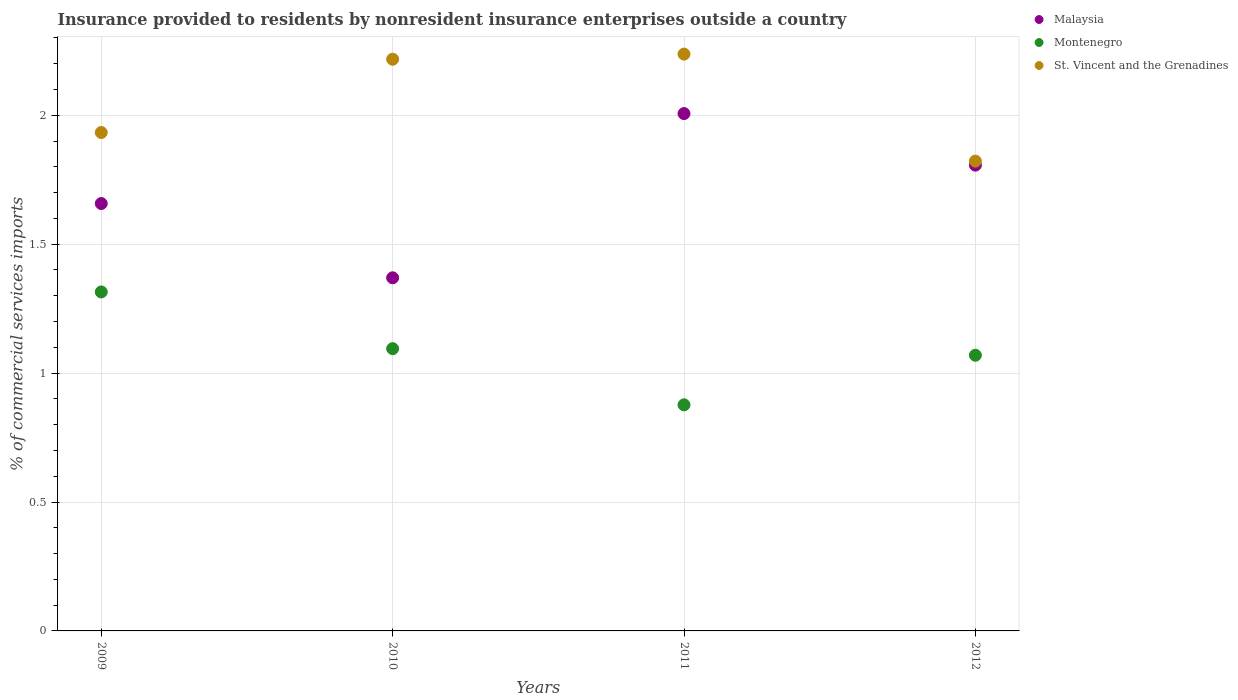How many different coloured dotlines are there?
Make the answer very short. 3. What is the Insurance provided to residents in Malaysia in 2012?
Your answer should be very brief. 1.81. Across all years, what is the maximum Insurance provided to residents in St. Vincent and the Grenadines?
Ensure brevity in your answer.  2.24. Across all years, what is the minimum Insurance provided to residents in Montenegro?
Your response must be concise. 0.88. In which year was the Insurance provided to residents in St. Vincent and the Grenadines maximum?
Offer a very short reply. 2011. What is the total Insurance provided to residents in Montenegro in the graph?
Offer a very short reply. 4.36. What is the difference between the Insurance provided to residents in Malaysia in 2009 and that in 2011?
Make the answer very short. -0.35. What is the difference between the Insurance provided to residents in St. Vincent and the Grenadines in 2010 and the Insurance provided to residents in Montenegro in 2012?
Give a very brief answer. 1.15. What is the average Insurance provided to residents in Montenegro per year?
Provide a succinct answer. 1.09. In the year 2009, what is the difference between the Insurance provided to residents in Malaysia and Insurance provided to residents in St. Vincent and the Grenadines?
Ensure brevity in your answer.  -0.28. What is the ratio of the Insurance provided to residents in Montenegro in 2010 to that in 2012?
Your answer should be compact. 1.02. What is the difference between the highest and the second highest Insurance provided to residents in St. Vincent and the Grenadines?
Ensure brevity in your answer.  0.02. What is the difference between the highest and the lowest Insurance provided to residents in St. Vincent and the Grenadines?
Make the answer very short. 0.42. Is the sum of the Insurance provided to residents in Malaysia in 2011 and 2012 greater than the maximum Insurance provided to residents in Montenegro across all years?
Offer a very short reply. Yes. Is the Insurance provided to residents in St. Vincent and the Grenadines strictly greater than the Insurance provided to residents in Malaysia over the years?
Make the answer very short. Yes. Is the Insurance provided to residents in Malaysia strictly less than the Insurance provided to residents in St. Vincent and the Grenadines over the years?
Offer a terse response. Yes. Does the graph contain any zero values?
Your answer should be very brief. No. Where does the legend appear in the graph?
Provide a succinct answer. Top right. How are the legend labels stacked?
Your answer should be very brief. Vertical. What is the title of the graph?
Make the answer very short. Insurance provided to residents by nonresident insurance enterprises outside a country. Does "Bolivia" appear as one of the legend labels in the graph?
Your response must be concise. No. What is the label or title of the Y-axis?
Offer a terse response. % of commercial services imports. What is the % of commercial services imports of Malaysia in 2009?
Keep it short and to the point. 1.66. What is the % of commercial services imports in Montenegro in 2009?
Make the answer very short. 1.31. What is the % of commercial services imports in St. Vincent and the Grenadines in 2009?
Your answer should be compact. 1.93. What is the % of commercial services imports of Malaysia in 2010?
Offer a terse response. 1.37. What is the % of commercial services imports in Montenegro in 2010?
Your response must be concise. 1.09. What is the % of commercial services imports in St. Vincent and the Grenadines in 2010?
Give a very brief answer. 2.22. What is the % of commercial services imports of Malaysia in 2011?
Keep it short and to the point. 2.01. What is the % of commercial services imports of Montenegro in 2011?
Keep it short and to the point. 0.88. What is the % of commercial services imports of St. Vincent and the Grenadines in 2011?
Offer a terse response. 2.24. What is the % of commercial services imports of Malaysia in 2012?
Your answer should be compact. 1.81. What is the % of commercial services imports in Montenegro in 2012?
Offer a very short reply. 1.07. What is the % of commercial services imports in St. Vincent and the Grenadines in 2012?
Offer a very short reply. 1.82. Across all years, what is the maximum % of commercial services imports of Malaysia?
Keep it short and to the point. 2.01. Across all years, what is the maximum % of commercial services imports in Montenegro?
Ensure brevity in your answer.  1.31. Across all years, what is the maximum % of commercial services imports in St. Vincent and the Grenadines?
Ensure brevity in your answer.  2.24. Across all years, what is the minimum % of commercial services imports in Malaysia?
Your answer should be compact. 1.37. Across all years, what is the minimum % of commercial services imports of Montenegro?
Provide a short and direct response. 0.88. Across all years, what is the minimum % of commercial services imports in St. Vincent and the Grenadines?
Your answer should be compact. 1.82. What is the total % of commercial services imports in Malaysia in the graph?
Give a very brief answer. 6.84. What is the total % of commercial services imports in Montenegro in the graph?
Give a very brief answer. 4.36. What is the total % of commercial services imports in St. Vincent and the Grenadines in the graph?
Your response must be concise. 8.21. What is the difference between the % of commercial services imports of Malaysia in 2009 and that in 2010?
Make the answer very short. 0.29. What is the difference between the % of commercial services imports of Montenegro in 2009 and that in 2010?
Ensure brevity in your answer.  0.22. What is the difference between the % of commercial services imports in St. Vincent and the Grenadines in 2009 and that in 2010?
Provide a succinct answer. -0.28. What is the difference between the % of commercial services imports in Malaysia in 2009 and that in 2011?
Your answer should be very brief. -0.35. What is the difference between the % of commercial services imports in Montenegro in 2009 and that in 2011?
Make the answer very short. 0.44. What is the difference between the % of commercial services imports in St. Vincent and the Grenadines in 2009 and that in 2011?
Your response must be concise. -0.3. What is the difference between the % of commercial services imports in Malaysia in 2009 and that in 2012?
Keep it short and to the point. -0.15. What is the difference between the % of commercial services imports in Montenegro in 2009 and that in 2012?
Your response must be concise. 0.25. What is the difference between the % of commercial services imports of St. Vincent and the Grenadines in 2009 and that in 2012?
Give a very brief answer. 0.11. What is the difference between the % of commercial services imports of Malaysia in 2010 and that in 2011?
Make the answer very short. -0.64. What is the difference between the % of commercial services imports of Montenegro in 2010 and that in 2011?
Give a very brief answer. 0.22. What is the difference between the % of commercial services imports in St. Vincent and the Grenadines in 2010 and that in 2011?
Your answer should be compact. -0.02. What is the difference between the % of commercial services imports of Malaysia in 2010 and that in 2012?
Offer a terse response. -0.44. What is the difference between the % of commercial services imports of Montenegro in 2010 and that in 2012?
Provide a short and direct response. 0.03. What is the difference between the % of commercial services imports of St. Vincent and the Grenadines in 2010 and that in 2012?
Keep it short and to the point. 0.4. What is the difference between the % of commercial services imports of Montenegro in 2011 and that in 2012?
Your answer should be very brief. -0.19. What is the difference between the % of commercial services imports of St. Vincent and the Grenadines in 2011 and that in 2012?
Provide a short and direct response. 0.41. What is the difference between the % of commercial services imports of Malaysia in 2009 and the % of commercial services imports of Montenegro in 2010?
Provide a short and direct response. 0.56. What is the difference between the % of commercial services imports of Malaysia in 2009 and the % of commercial services imports of St. Vincent and the Grenadines in 2010?
Offer a very short reply. -0.56. What is the difference between the % of commercial services imports of Montenegro in 2009 and the % of commercial services imports of St. Vincent and the Grenadines in 2010?
Give a very brief answer. -0.9. What is the difference between the % of commercial services imports in Malaysia in 2009 and the % of commercial services imports in Montenegro in 2011?
Your answer should be very brief. 0.78. What is the difference between the % of commercial services imports of Malaysia in 2009 and the % of commercial services imports of St. Vincent and the Grenadines in 2011?
Offer a very short reply. -0.58. What is the difference between the % of commercial services imports in Montenegro in 2009 and the % of commercial services imports in St. Vincent and the Grenadines in 2011?
Your answer should be very brief. -0.92. What is the difference between the % of commercial services imports in Malaysia in 2009 and the % of commercial services imports in Montenegro in 2012?
Provide a succinct answer. 0.59. What is the difference between the % of commercial services imports of Malaysia in 2009 and the % of commercial services imports of St. Vincent and the Grenadines in 2012?
Give a very brief answer. -0.16. What is the difference between the % of commercial services imports of Montenegro in 2009 and the % of commercial services imports of St. Vincent and the Grenadines in 2012?
Give a very brief answer. -0.51. What is the difference between the % of commercial services imports in Malaysia in 2010 and the % of commercial services imports in Montenegro in 2011?
Offer a very short reply. 0.49. What is the difference between the % of commercial services imports in Malaysia in 2010 and the % of commercial services imports in St. Vincent and the Grenadines in 2011?
Provide a succinct answer. -0.87. What is the difference between the % of commercial services imports in Montenegro in 2010 and the % of commercial services imports in St. Vincent and the Grenadines in 2011?
Keep it short and to the point. -1.14. What is the difference between the % of commercial services imports in Malaysia in 2010 and the % of commercial services imports in Montenegro in 2012?
Keep it short and to the point. 0.3. What is the difference between the % of commercial services imports of Malaysia in 2010 and the % of commercial services imports of St. Vincent and the Grenadines in 2012?
Keep it short and to the point. -0.45. What is the difference between the % of commercial services imports of Montenegro in 2010 and the % of commercial services imports of St. Vincent and the Grenadines in 2012?
Provide a short and direct response. -0.73. What is the difference between the % of commercial services imports in Malaysia in 2011 and the % of commercial services imports in Montenegro in 2012?
Keep it short and to the point. 0.94. What is the difference between the % of commercial services imports in Malaysia in 2011 and the % of commercial services imports in St. Vincent and the Grenadines in 2012?
Keep it short and to the point. 0.18. What is the difference between the % of commercial services imports of Montenegro in 2011 and the % of commercial services imports of St. Vincent and the Grenadines in 2012?
Provide a short and direct response. -0.95. What is the average % of commercial services imports of Malaysia per year?
Provide a succinct answer. 1.71. What is the average % of commercial services imports of Montenegro per year?
Offer a very short reply. 1.09. What is the average % of commercial services imports in St. Vincent and the Grenadines per year?
Your response must be concise. 2.05. In the year 2009, what is the difference between the % of commercial services imports of Malaysia and % of commercial services imports of Montenegro?
Offer a very short reply. 0.34. In the year 2009, what is the difference between the % of commercial services imports of Malaysia and % of commercial services imports of St. Vincent and the Grenadines?
Give a very brief answer. -0.28. In the year 2009, what is the difference between the % of commercial services imports in Montenegro and % of commercial services imports in St. Vincent and the Grenadines?
Give a very brief answer. -0.62. In the year 2010, what is the difference between the % of commercial services imports of Malaysia and % of commercial services imports of Montenegro?
Keep it short and to the point. 0.27. In the year 2010, what is the difference between the % of commercial services imports of Malaysia and % of commercial services imports of St. Vincent and the Grenadines?
Offer a terse response. -0.85. In the year 2010, what is the difference between the % of commercial services imports of Montenegro and % of commercial services imports of St. Vincent and the Grenadines?
Your answer should be very brief. -1.12. In the year 2011, what is the difference between the % of commercial services imports of Malaysia and % of commercial services imports of Montenegro?
Provide a short and direct response. 1.13. In the year 2011, what is the difference between the % of commercial services imports of Malaysia and % of commercial services imports of St. Vincent and the Grenadines?
Give a very brief answer. -0.23. In the year 2011, what is the difference between the % of commercial services imports of Montenegro and % of commercial services imports of St. Vincent and the Grenadines?
Provide a short and direct response. -1.36. In the year 2012, what is the difference between the % of commercial services imports in Malaysia and % of commercial services imports in Montenegro?
Give a very brief answer. 0.74. In the year 2012, what is the difference between the % of commercial services imports in Malaysia and % of commercial services imports in St. Vincent and the Grenadines?
Ensure brevity in your answer.  -0.02. In the year 2012, what is the difference between the % of commercial services imports of Montenegro and % of commercial services imports of St. Vincent and the Grenadines?
Provide a succinct answer. -0.75. What is the ratio of the % of commercial services imports of Malaysia in 2009 to that in 2010?
Provide a short and direct response. 1.21. What is the ratio of the % of commercial services imports in Montenegro in 2009 to that in 2010?
Make the answer very short. 1.2. What is the ratio of the % of commercial services imports of St. Vincent and the Grenadines in 2009 to that in 2010?
Keep it short and to the point. 0.87. What is the ratio of the % of commercial services imports of Malaysia in 2009 to that in 2011?
Provide a short and direct response. 0.83. What is the ratio of the % of commercial services imports in Montenegro in 2009 to that in 2011?
Offer a terse response. 1.5. What is the ratio of the % of commercial services imports in St. Vincent and the Grenadines in 2009 to that in 2011?
Your answer should be compact. 0.86. What is the ratio of the % of commercial services imports of Malaysia in 2009 to that in 2012?
Your answer should be very brief. 0.92. What is the ratio of the % of commercial services imports of Montenegro in 2009 to that in 2012?
Ensure brevity in your answer.  1.23. What is the ratio of the % of commercial services imports of St. Vincent and the Grenadines in 2009 to that in 2012?
Your response must be concise. 1.06. What is the ratio of the % of commercial services imports of Malaysia in 2010 to that in 2011?
Ensure brevity in your answer.  0.68. What is the ratio of the % of commercial services imports in Montenegro in 2010 to that in 2011?
Your answer should be very brief. 1.25. What is the ratio of the % of commercial services imports in Malaysia in 2010 to that in 2012?
Make the answer very short. 0.76. What is the ratio of the % of commercial services imports of Montenegro in 2010 to that in 2012?
Your answer should be very brief. 1.02. What is the ratio of the % of commercial services imports of St. Vincent and the Grenadines in 2010 to that in 2012?
Offer a terse response. 1.22. What is the ratio of the % of commercial services imports of Malaysia in 2011 to that in 2012?
Offer a terse response. 1.11. What is the ratio of the % of commercial services imports in Montenegro in 2011 to that in 2012?
Give a very brief answer. 0.82. What is the ratio of the % of commercial services imports in St. Vincent and the Grenadines in 2011 to that in 2012?
Your answer should be compact. 1.23. What is the difference between the highest and the second highest % of commercial services imports of Montenegro?
Ensure brevity in your answer.  0.22. What is the difference between the highest and the second highest % of commercial services imports of St. Vincent and the Grenadines?
Offer a very short reply. 0.02. What is the difference between the highest and the lowest % of commercial services imports in Malaysia?
Offer a terse response. 0.64. What is the difference between the highest and the lowest % of commercial services imports in Montenegro?
Keep it short and to the point. 0.44. What is the difference between the highest and the lowest % of commercial services imports in St. Vincent and the Grenadines?
Offer a terse response. 0.41. 